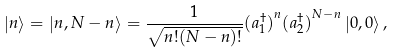Convert formula to latex. <formula><loc_0><loc_0><loc_500><loc_500>\left | n \right > = \left | n , N - n \right > = \frac { 1 } { \sqrt { n ! ( N - n ) ! } } { ( a _ { 1 } ^ { \dagger } ) } ^ { n } { ( a _ { 2 } ^ { \dagger } ) } ^ { N - n } \left | 0 , 0 \right > ,</formula> 